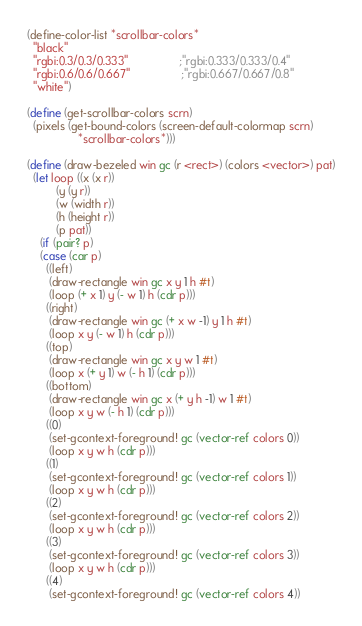Convert code to text. <code><loc_0><loc_0><loc_500><loc_500><_Scheme_>
(define-color-list *scrollbar-colors*
  "black"
  "rgbi:0.3/0.3/0.333"				;"rgbi:0.333/0.333/0.4"
  "rgbi:0.6/0.6/0.667"				;"rgbi:0.667/0.667/0.8"
  "white")

(define (get-scrollbar-colors scrn)
  (pixels (get-bound-colors (screen-default-colormap scrn) 
			    *scrollbar-colors*)))

(define (draw-bezeled win gc (r <rect>) (colors <vector>) pat)
  (let loop ((x (x r))
	     (y (y r))
	     (w (width r))
	     (h (height r))
	     (p pat))
    (if (pair? p)
	(case (car p)
	  ((left)
	   (draw-rectangle win gc x y 1 h #t)
	   (loop (+ x 1) y (- w 1) h (cdr p)))
	  ((right)
	   (draw-rectangle win gc (+ x w -1) y 1 h #t)
	   (loop x y (- w 1) h (cdr p)))
	  ((top)
	   (draw-rectangle win gc x y w 1 #t)
	   (loop x (+ y 1) w (- h 1) (cdr p)))
	  ((bottom)
	   (draw-rectangle win gc x (+ y h -1) w 1 #t)
	   (loop x y w (- h 1) (cdr p)))
	  ((0)
	   (set-gcontext-foreground! gc (vector-ref colors 0))
	   (loop x y w h (cdr p)))
	  ((1)
	   (set-gcontext-foreground! gc (vector-ref colors 1))
	   (loop x y w h (cdr p)))
	  ((2)
	   (set-gcontext-foreground! gc (vector-ref colors 2))
	   (loop x y w h (cdr p)))
	  ((3)
	   (set-gcontext-foreground! gc (vector-ref colors 3))
	   (loop x y w h (cdr p)))
	  ((4)
	   (set-gcontext-foreground! gc (vector-ref colors 4))</code> 